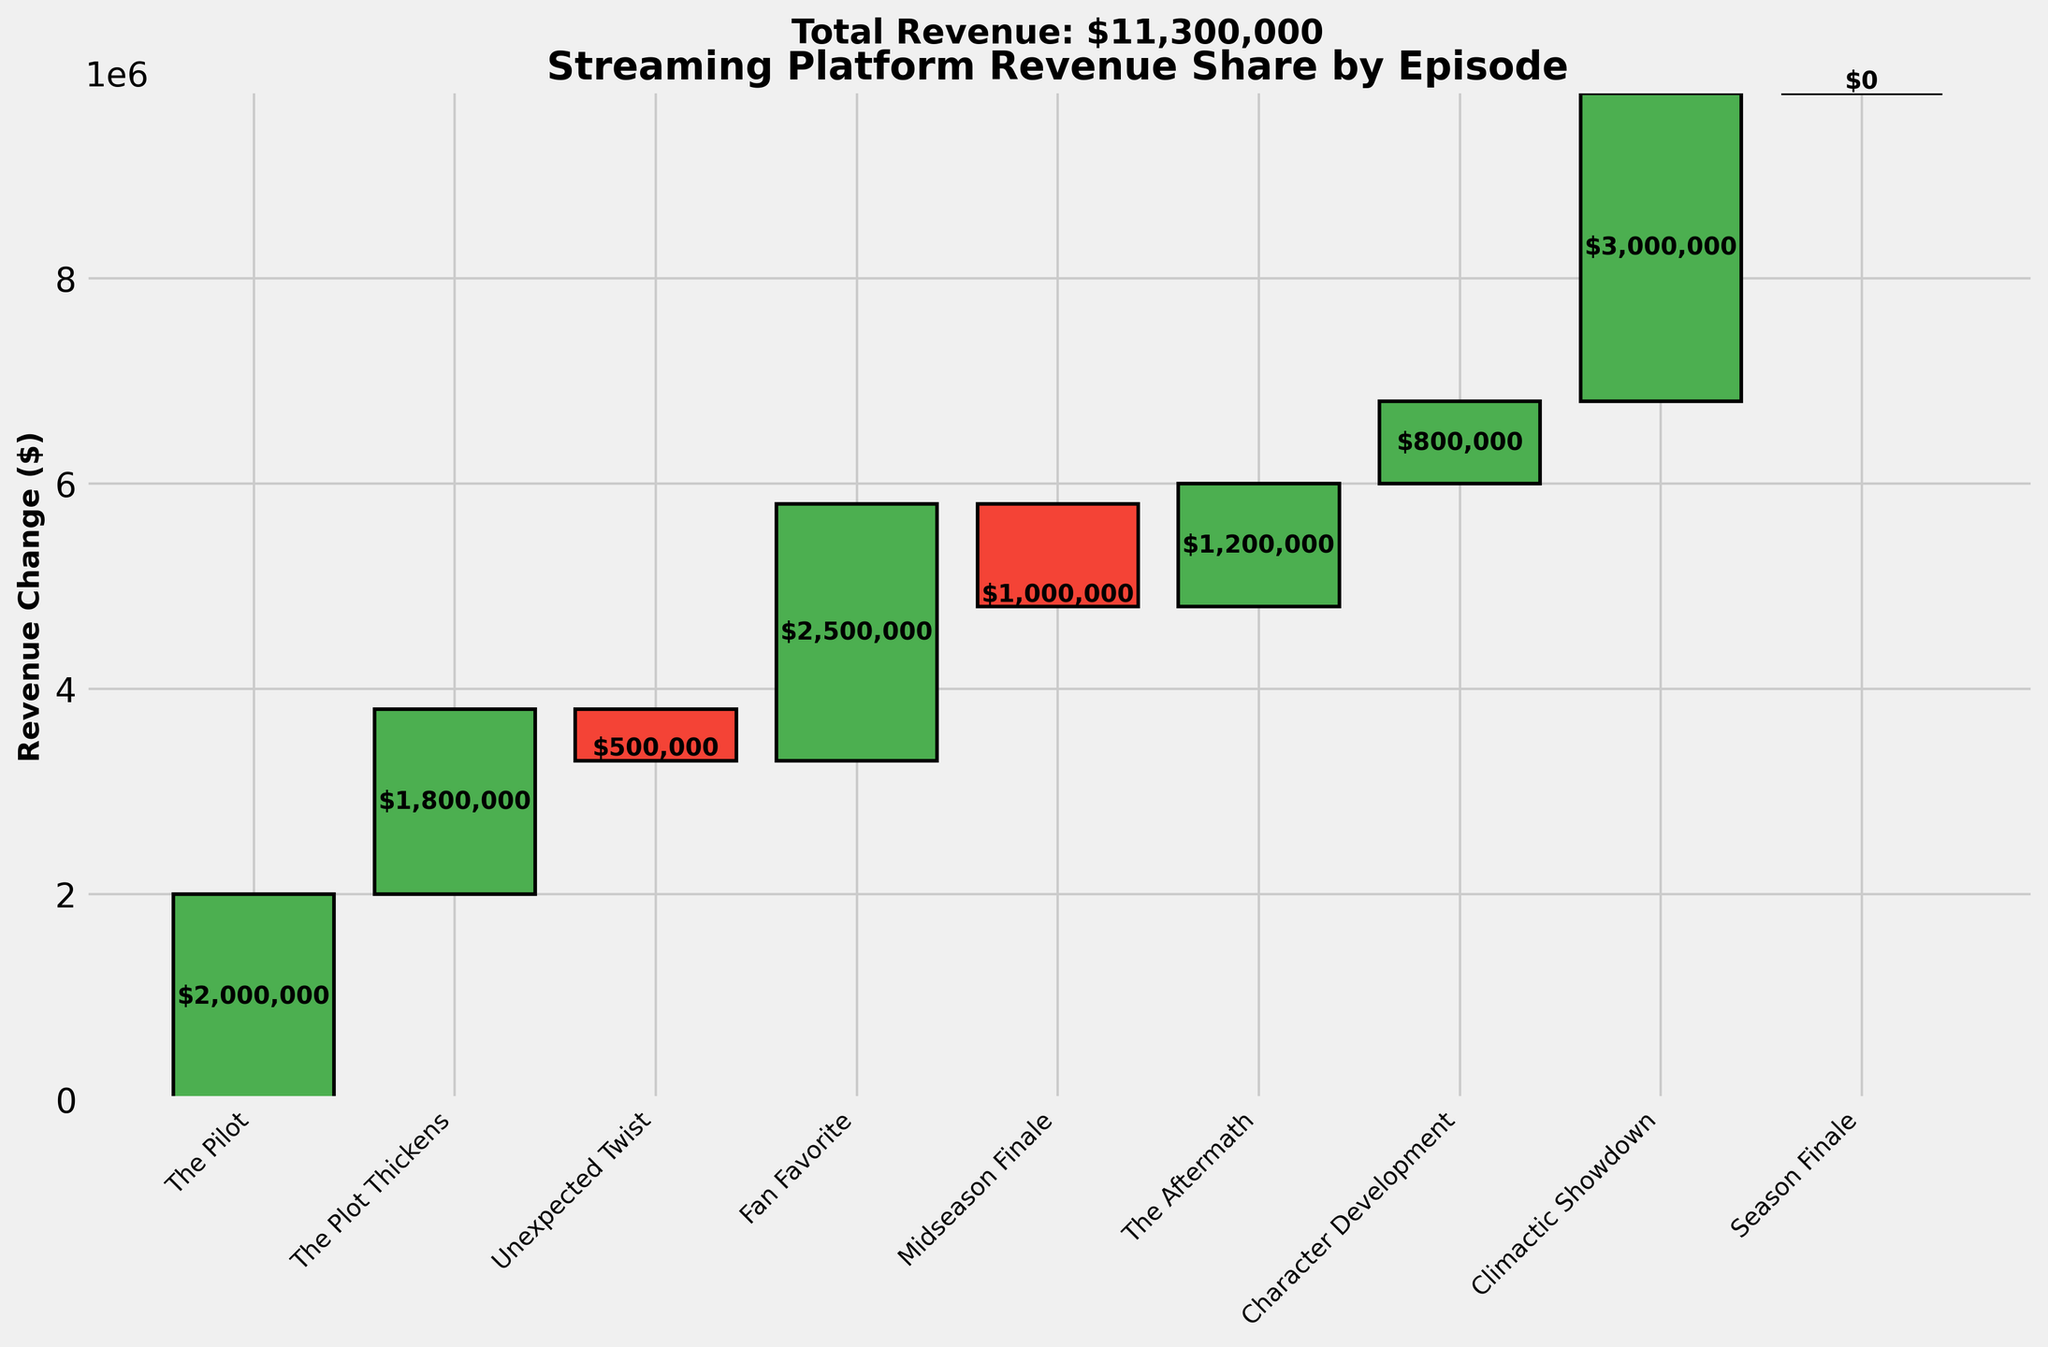What is the title of the chart? The title is usually located at the top of the chart. It provides a summary of what the chart is about. Here, we can read the title at the top, which is "Streaming Platform Revenue Share by Episode."
Answer: Streaming Platform Revenue Share by Episode How many episodes are displayed in the chart? We can count the number of tick labels along the x-axis, each representing a different episode. There are labels for nine episodes ("The Pilot" to "Season Finale").
Answer: 9 Which episode had the highest revenue increase? By looking at the bars, we can identify the tallest green bar since green bars indicate revenue increases. "Climactic Showdown" is the episode with the tallest green bar.
Answer: Climactic Showdown Which episode resulted in the largest decrease in revenue? The largest decrease in revenue is indicated by the tallest red bar. The "Midseason Finale" has the tallest red bar, indicating the largest decrease.
Answer: Midseason Finale What is the total revenue by the end of the "Season Finale"? The total revenue is typically shown in the final bar or at the top of the chart. Here, the total revenue is displayed as $11,300,000.
Answer: $11,300,000 What is the change in revenue from "The Pilot" to "The Plot Thickens"? We find the changes in the data for these episodes. "The Pilot" had a change of $2,000,000 and "The Plot Thickens" had a change of $1,800,000.
Answer: $2,000,000 to $1,800,000 How much did the revenue increase from "Character Development" to "Climactic Showdown"? From the bars for "Character Development" and "Climactic Showdown", we find the revenue increases. Character Development is $800,000, and Climactic Showdown is $3,000,000. The increase is $3,000,000 - $800,000.
Answer: $2,200,000 Between "The Aftermath" and "Character Development," which episode contributed more to the total revenue? By comparing the heights of the green bars for these two episodes: "The Aftermath" has $1,200,000 and "Character Development" has $800,000. Here, $1,200,000 > $800,000.
Answer: The Aftermath What was the cumulative revenue at the end of "Fan Favorite"? To find this, we sum up the cumulative revenue up to and including "Fan Favorite." Starting from $1,500,000, add $2,000,000 for "The Pilot," $1,800,000 for "The Plot Thickens," -$500,000 for "Unexpected Twist," and $2,500,000 for "Fan Favorite."
Answer: $4,800,000 Was there any episode where the change in revenue was zero? A change of zero would imply that there was no increase or decrease represented. The chart and data indicate that revenue changes for each episode, but there's no zero change for any episode before "Season Finale," where revenue change is already totaled.
Answer: No 